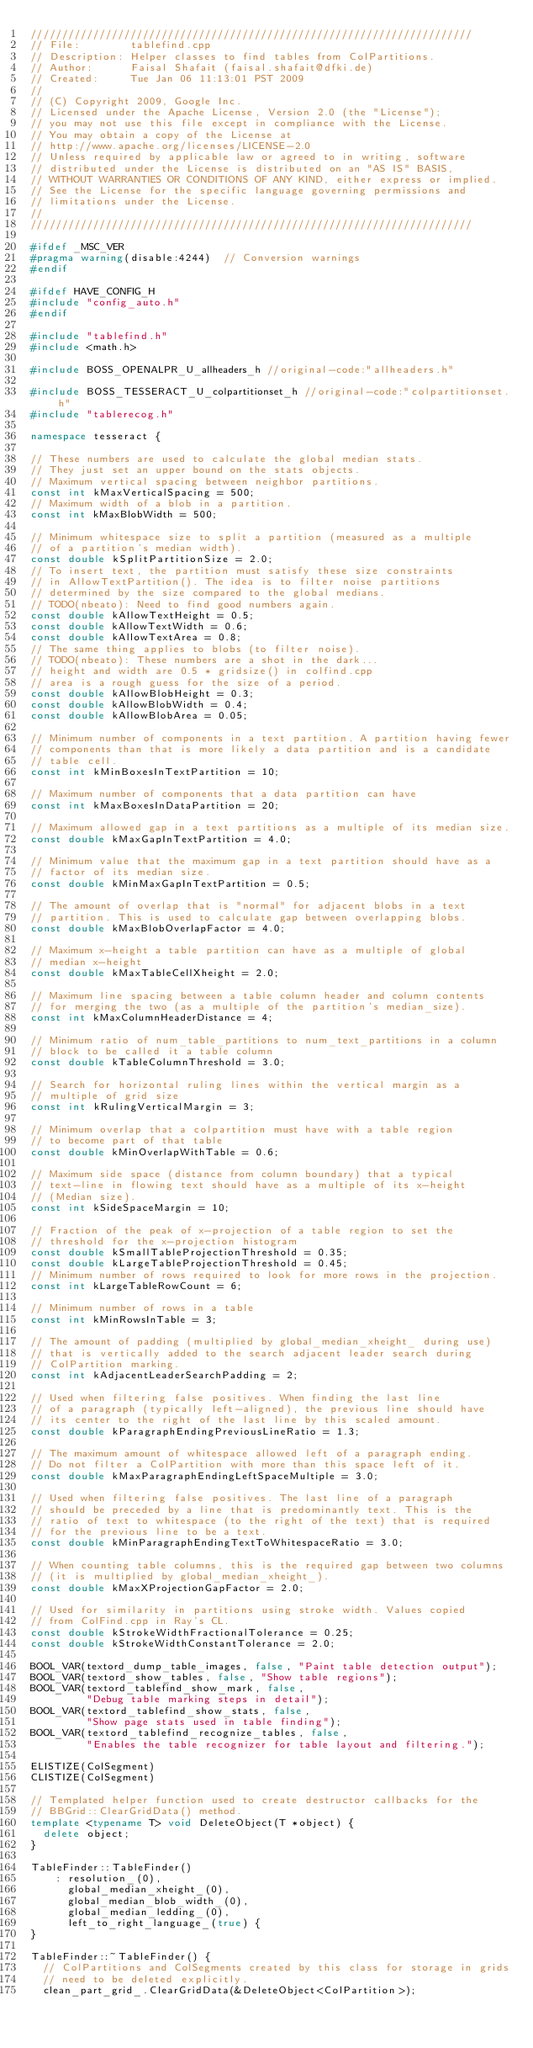Convert code to text. <code><loc_0><loc_0><loc_500><loc_500><_C++_>///////////////////////////////////////////////////////////////////////
// File:        tablefind.cpp
// Description: Helper classes to find tables from ColPartitions.
// Author:      Faisal Shafait (faisal.shafait@dfki.de)
// Created:     Tue Jan 06 11:13:01 PST 2009
//
// (C) Copyright 2009, Google Inc.
// Licensed under the Apache License, Version 2.0 (the "License");
// you may not use this file except in compliance with the License.
// You may obtain a copy of the License at
// http://www.apache.org/licenses/LICENSE-2.0
// Unless required by applicable law or agreed to in writing, software
// distributed under the License is distributed on an "AS IS" BASIS,
// WITHOUT WARRANTIES OR CONDITIONS OF ANY KIND, either express or implied.
// See the License for the specific language governing permissions and
// limitations under the License.
//
///////////////////////////////////////////////////////////////////////

#ifdef _MSC_VER
#pragma warning(disable:4244)  // Conversion warnings
#endif

#ifdef HAVE_CONFIG_H
#include "config_auto.h"
#endif

#include "tablefind.h"
#include <math.h>

#include BOSS_OPENALPR_U_allheaders_h //original-code:"allheaders.h"

#include BOSS_TESSERACT_U_colpartitionset_h //original-code:"colpartitionset.h"
#include "tablerecog.h"

namespace tesseract {

// These numbers are used to calculate the global median stats.
// They just set an upper bound on the stats objects.
// Maximum vertical spacing between neighbor partitions.
const int kMaxVerticalSpacing = 500;
// Maximum width of a blob in a partition.
const int kMaxBlobWidth = 500;

// Minimum whitespace size to split a partition (measured as a multiple
// of a partition's median width).
const double kSplitPartitionSize = 2.0;
// To insert text, the partition must satisfy these size constraints
// in AllowTextPartition(). The idea is to filter noise partitions
// determined by the size compared to the global medians.
// TODO(nbeato): Need to find good numbers again.
const double kAllowTextHeight = 0.5;
const double kAllowTextWidth = 0.6;
const double kAllowTextArea = 0.8;
// The same thing applies to blobs (to filter noise).
// TODO(nbeato): These numbers are a shot in the dark...
// height and width are 0.5 * gridsize() in colfind.cpp
// area is a rough guess for the size of a period.
const double kAllowBlobHeight = 0.3;
const double kAllowBlobWidth = 0.4;
const double kAllowBlobArea = 0.05;

// Minimum number of components in a text partition. A partition having fewer
// components than that is more likely a data partition and is a candidate
// table cell.
const int kMinBoxesInTextPartition = 10;

// Maximum number of components that a data partition can have
const int kMaxBoxesInDataPartition = 20;

// Maximum allowed gap in a text partitions as a multiple of its median size.
const double kMaxGapInTextPartition = 4.0;

// Minimum value that the maximum gap in a text partition should have as a
// factor of its median size.
const double kMinMaxGapInTextPartition = 0.5;

// The amount of overlap that is "normal" for adjacent blobs in a text
// partition. This is used to calculate gap between overlapping blobs.
const double kMaxBlobOverlapFactor = 4.0;

// Maximum x-height a table partition can have as a multiple of global
// median x-height
const double kMaxTableCellXheight = 2.0;

// Maximum line spacing between a table column header and column contents
// for merging the two (as a multiple of the partition's median_size).
const int kMaxColumnHeaderDistance = 4;

// Minimum ratio of num_table_partitions to num_text_partitions in a column
// block to be called it a table column
const double kTableColumnThreshold = 3.0;

// Search for horizontal ruling lines within the vertical margin as a
// multiple of grid size
const int kRulingVerticalMargin = 3;

// Minimum overlap that a colpartition must have with a table region
// to become part of that table
const double kMinOverlapWithTable = 0.6;

// Maximum side space (distance from column boundary) that a typical
// text-line in flowing text should have as a multiple of its x-height
// (Median size).
const int kSideSpaceMargin = 10;

// Fraction of the peak of x-projection of a table region to set the
// threshold for the x-projection histogram
const double kSmallTableProjectionThreshold = 0.35;
const double kLargeTableProjectionThreshold = 0.45;
// Minimum number of rows required to look for more rows in the projection.
const int kLargeTableRowCount = 6;

// Minimum number of rows in a table
const int kMinRowsInTable = 3;

// The amount of padding (multiplied by global_median_xheight_ during use)
// that is vertically added to the search adjacent leader search during
// ColPartition marking.
const int kAdjacentLeaderSearchPadding = 2;

// Used when filtering false positives. When finding the last line
// of a paragraph (typically left-aligned), the previous line should have
// its center to the right of the last line by this scaled amount.
const double kParagraphEndingPreviousLineRatio = 1.3;

// The maximum amount of whitespace allowed left of a paragraph ending.
// Do not filter a ColPartition with more than this space left of it.
const double kMaxParagraphEndingLeftSpaceMultiple = 3.0;

// Used when filtering false positives. The last line of a paragraph
// should be preceded by a line that is predominantly text. This is the
// ratio of text to whitespace (to the right of the text) that is required
// for the previous line to be a text.
const double kMinParagraphEndingTextToWhitespaceRatio = 3.0;

// When counting table columns, this is the required gap between two columns
// (it is multiplied by global_median_xheight_).
const double kMaxXProjectionGapFactor = 2.0;

// Used for similarity in partitions using stroke width. Values copied
// from ColFind.cpp in Ray's CL.
const double kStrokeWidthFractionalTolerance = 0.25;
const double kStrokeWidthConstantTolerance = 2.0;

BOOL_VAR(textord_dump_table_images, false, "Paint table detection output");
BOOL_VAR(textord_show_tables, false, "Show table regions");
BOOL_VAR(textord_tablefind_show_mark, false,
         "Debug table marking steps in detail");
BOOL_VAR(textord_tablefind_show_stats, false,
         "Show page stats used in table finding");
BOOL_VAR(textord_tablefind_recognize_tables, false,
         "Enables the table recognizer for table layout and filtering.");

ELISTIZE(ColSegment)
CLISTIZE(ColSegment)

// Templated helper function used to create destructor callbacks for the
// BBGrid::ClearGridData() method.
template <typename T> void DeleteObject(T *object) {
  delete object;
}

TableFinder::TableFinder()
    : resolution_(0),
      global_median_xheight_(0),
      global_median_blob_width_(0),
      global_median_ledding_(0),
      left_to_right_language_(true) {
}

TableFinder::~TableFinder() {
  // ColPartitions and ColSegments created by this class for storage in grids
  // need to be deleted explicitly.
  clean_part_grid_.ClearGridData(&DeleteObject<ColPartition>);</code> 